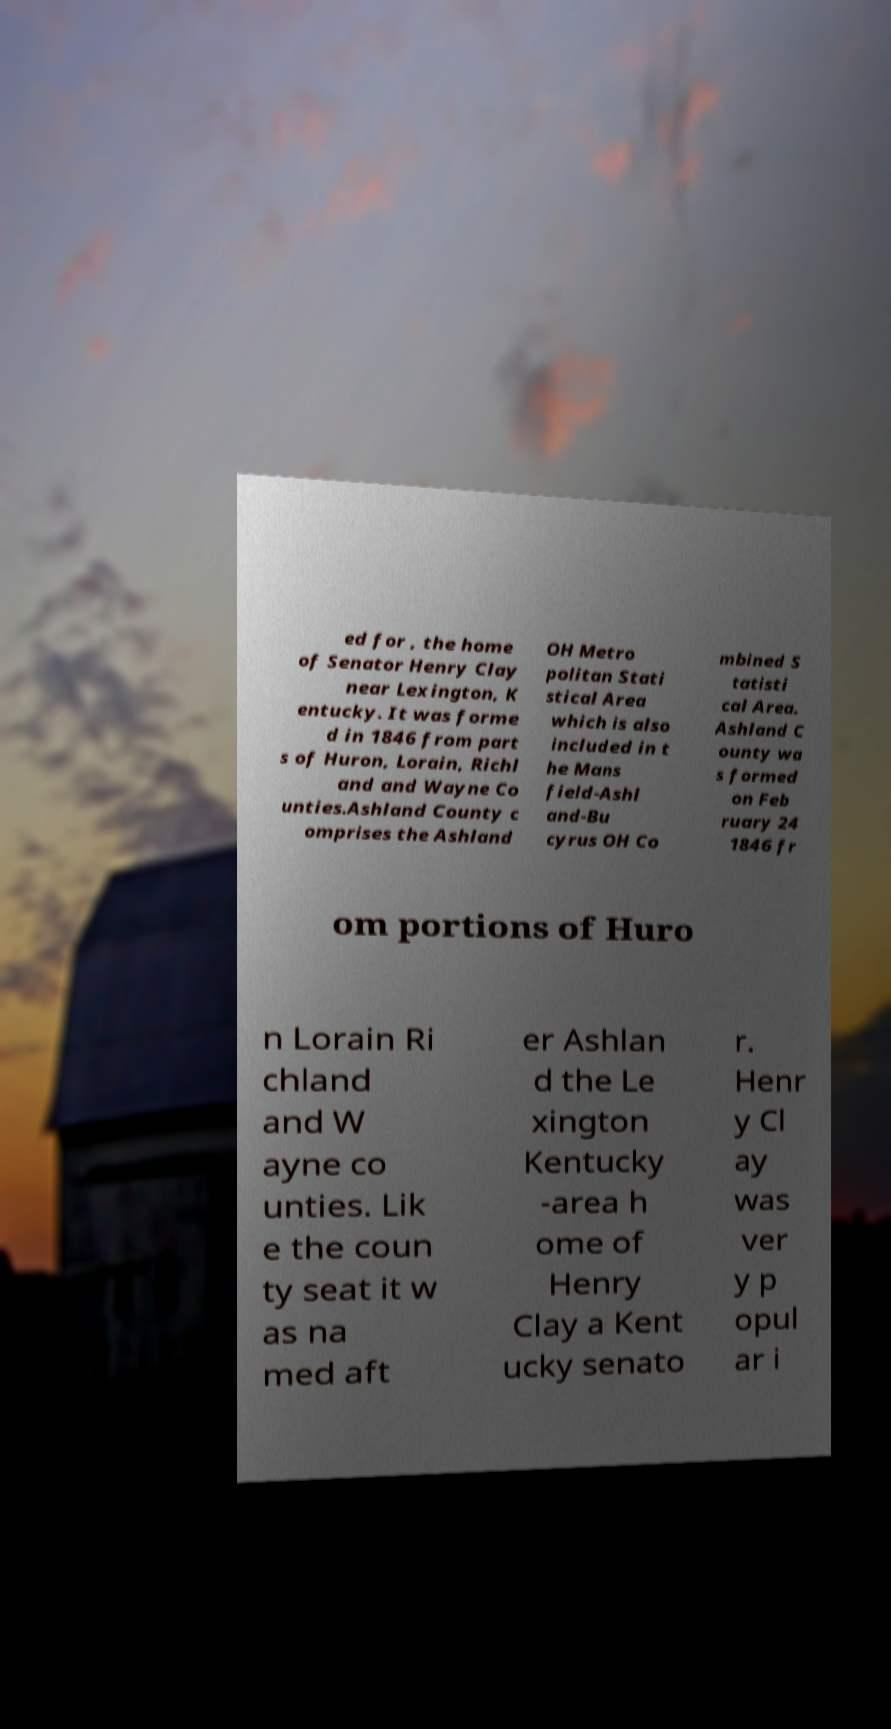What messages or text are displayed in this image? I need them in a readable, typed format. ed for , the home of Senator Henry Clay near Lexington, K entucky. It was forme d in 1846 from part s of Huron, Lorain, Richl and and Wayne Co unties.Ashland County c omprises the Ashland OH Metro politan Stati stical Area which is also included in t he Mans field-Ashl and-Bu cyrus OH Co mbined S tatisti cal Area. Ashland C ounty wa s formed on Feb ruary 24 1846 fr om portions of Huro n Lorain Ri chland and W ayne co unties. Lik e the coun ty seat it w as na med aft er Ashlan d the Le xington Kentucky -area h ome of Henry Clay a Kent ucky senato r. Henr y Cl ay was ver y p opul ar i 